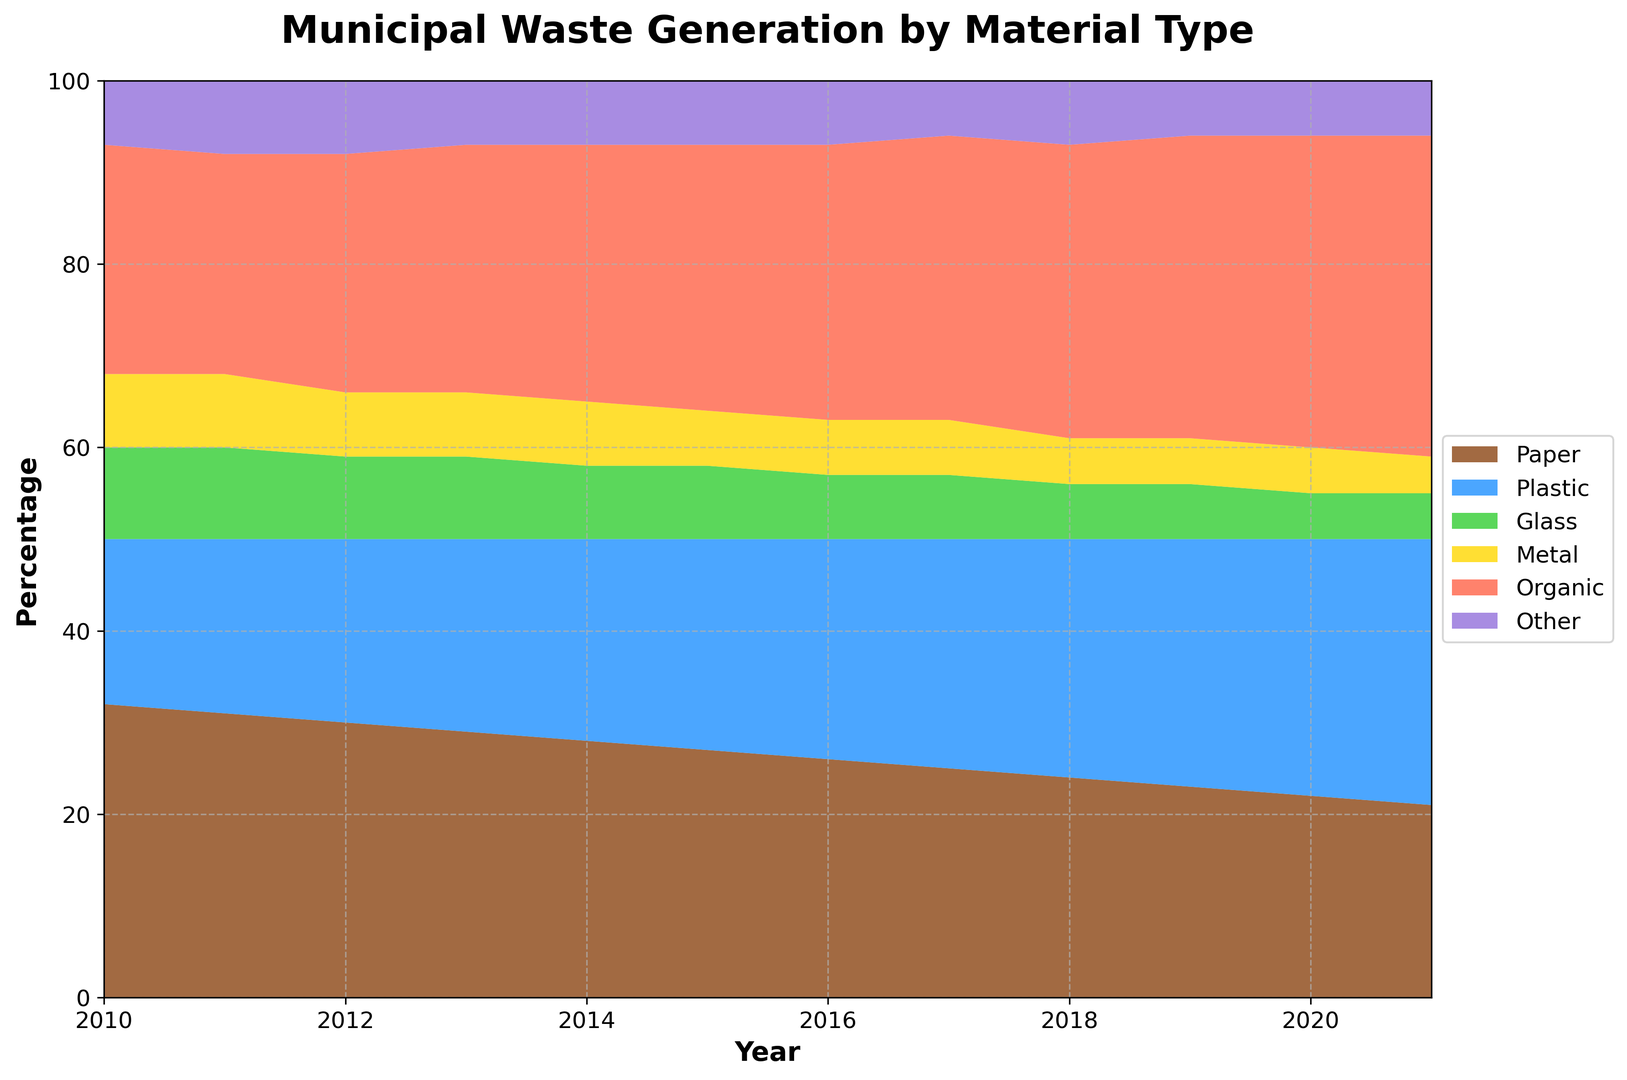What material had the highest percentage in 2021? By visually analyzing the area plot, the 'Organic' material occupies the largest area in 2021, indicating it has the highest percentage compared to the other materials.
Answer: Organic How has the percentage of 'Paper' waste changed from 2010 to 2021? Observing the area chart from 2010 to 2021, 'Paper' has a steadily declining trend in its area over the years, showing a decrease each year.
Answer: Decreased Which material saw the biggest increase in percentage from 2010 to 2021? By looking at the difference in area size from 2010 to 2021 for all materials, 'Organic' waste has significantly increased its area, indicating the biggest increase in percentage.
Answer: Organic Between 2015 and 2017, which material’s percentage remained constant? Checking the size of the areas for each material between 2015 and 2017, 'Metal' shows a constant percentage since its area does not change over these years.
Answer: Metal In 2019, what are the percentages of 'Glass' and 'Plastic' wastes combined? From the area chart, 'Glass' is 6% and 'Plastic' is 27% in 2019. Adding these values together gives 6 + 27 = 33%.
Answer: 33% Which material had a smaller percentage than 'Paper' in every year from 2010 to 2021? Comparing the areas associated with 'Other' to 'Paper' every year from 2010 to 2021, 'Other' consistently occupies a smaller space than 'Paper'.
Answer: Other How does the percentage of 'Plastic' in 2016 compare to its percentage in 2010? The chart shows 'Plastic' is larger in 2016 at 24% compared to 18% in 2010, indicating it has increased.
Answer: Increased What is the average percentage of 'Organic' from 2010 to 2021? Calculate the mean of the 'Organic' percentages: (25 + 24 + 26 + 27 + 28 + 29 + 30 + 31 + 32 + 33 + 34 + 35) / 12. The sum is 354, so the average is 354 / 12 = 29.5%.
Answer: 29.5% Which material had the smallest percentage in 2010 and did this material see a peak higher than 10% at any point between 2010 and 2021? Observing the areas, 'Other' had the smallest percentage in 2010 at 7%. 'Other' did not peak higher than 8% at any point between 2010 and 2021.
Answer: Other, No In which year did 'Glass' drop below 10% for the first time? By tracing the 'Glass' area across the years, it dropped below 10% for the first time in 2012 when it reached 9%.
Answer: 2012 